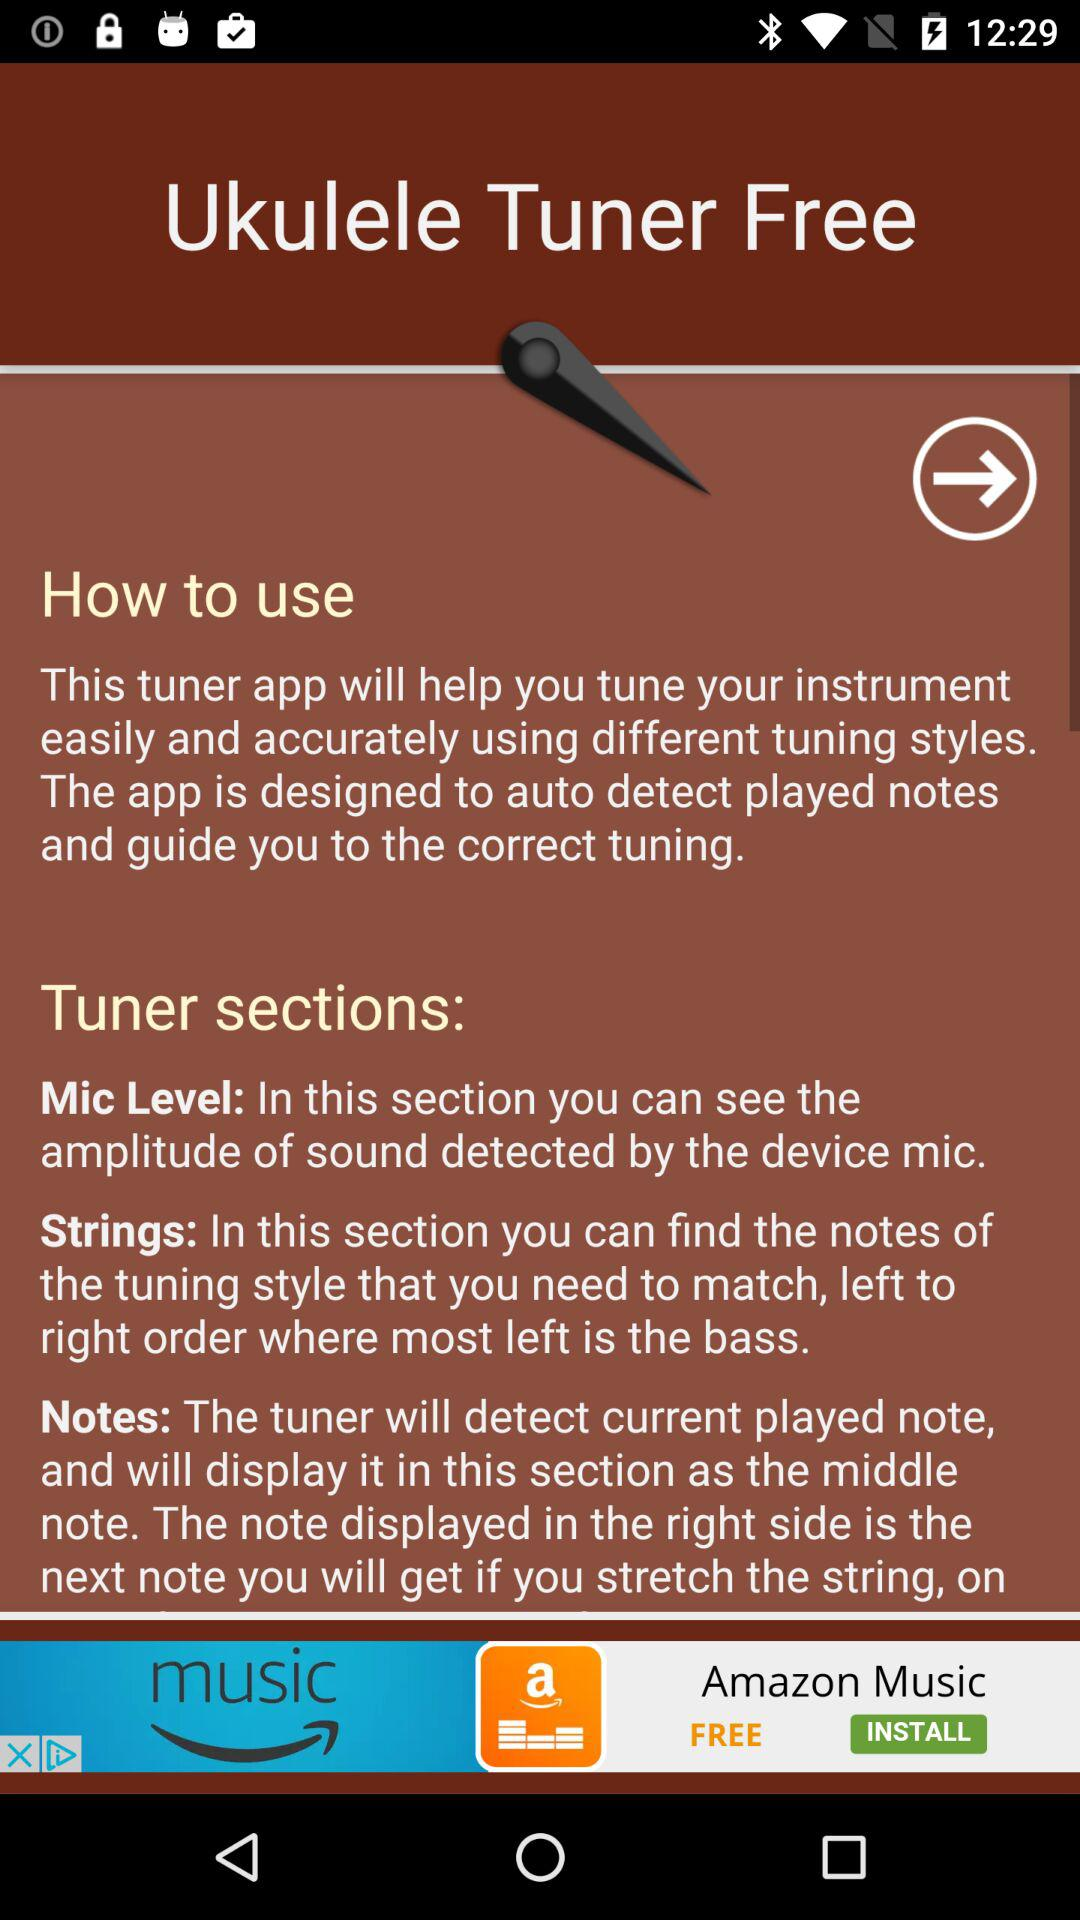What are the different sections of the tuner application? The different sections of the tuner application are "Mic Level", "Strings" and "Notes". 